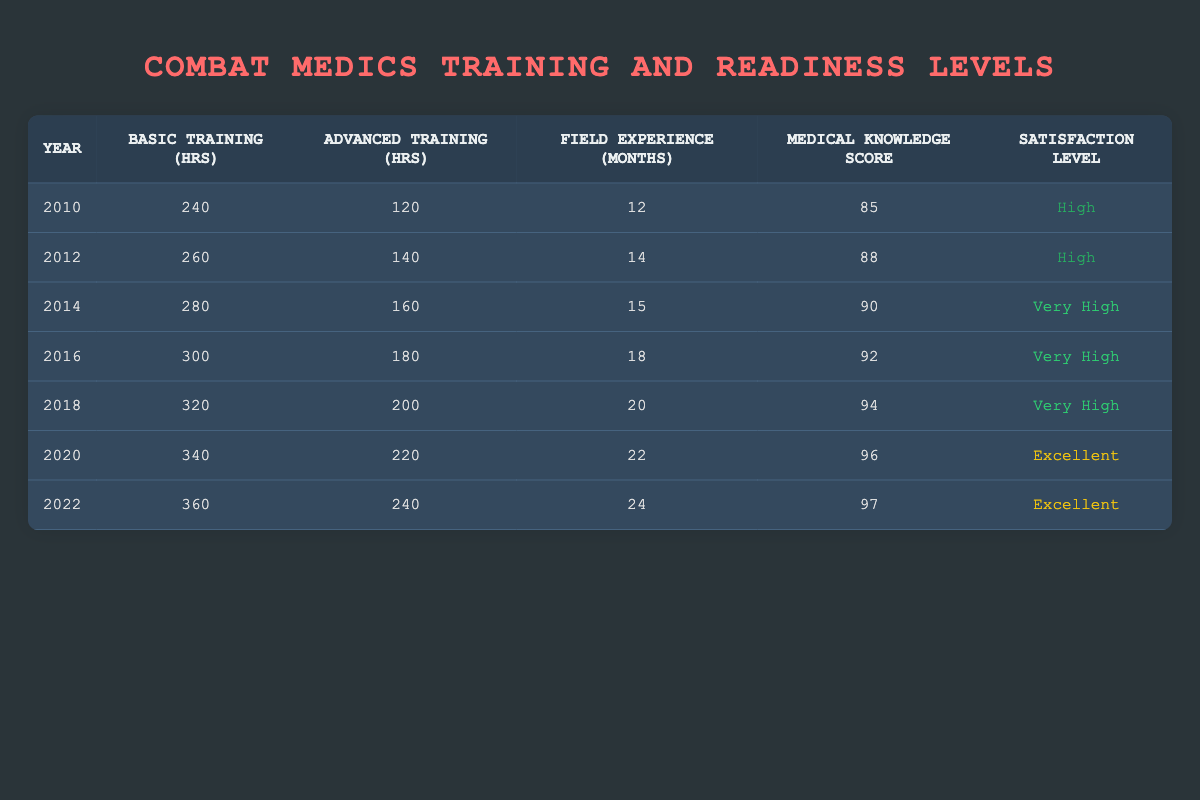What was the medical knowledge assessment score in 2014? From the table, we can find the row for the year 2014, which shows a medical knowledge assessment score of 90.
Answer: 90 How many hours of advanced training did combat medics receive in 2020? Looking at the row for the year 2020, the column for advanced training hours indicates 220 hours.
Answer: 220 What is the satisfaction level in the year 2016? In the row for 2016, the satisfaction level is described as "Very High," as stated in the corresponding column.
Answer: Very High What is the total number of basic training hours provided from 2010 to 2022? To find the total, we sum the basic training hours from each year: 240 + 260 + 280 + 300 + 320 + 340 + 360 = 2280 hours.
Answer: 2280 Is the satisfaction level in 2012 higher than the satisfaction level in 2014? The satisfaction level for 2012 is "High," while for 2014 it is "Very High." Thus, 2012 is not higher than 2014.
Answer: No What are the changes in field experience months from 2010 to 2022? In 2010, field experience was 12 months; in 2022 it rose to 24 months. The increase is 24 - 12 = 12 months.
Answer: Increased by 12 months What was the average medical knowledge assessment score for the years 2010-2022? The scores are 85, 88, 90, 92, 94, 96, and 97. Adding these gives 85 + 88 + 90 + 92 + 94 + 96 + 97 = 682. Dividing by 7 (the number of years) gives an average score of 682 / 7 = approximately 97.43.
Answer: Approximately 97.43 In which year did combat medics first report a satisfaction level rated as "Excellent"? The table indicates that the first instance of "Excellent" satisfaction level occurs in 2020.
Answer: 2020 What year showed the highest basic training hours? From the table, the highest value for basic training hours is in 2022, which shows 360 hours.
Answer: 2022 